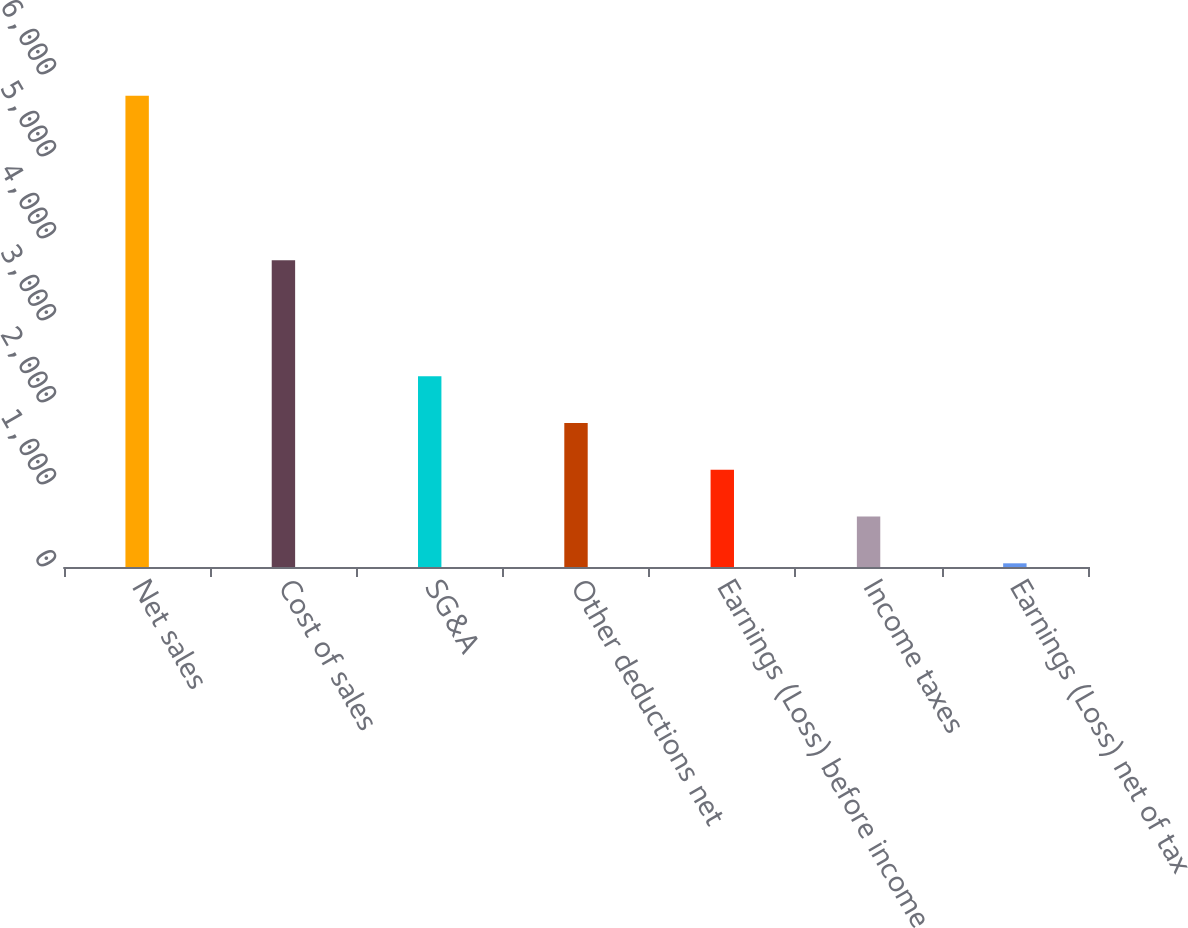Convert chart. <chart><loc_0><loc_0><loc_500><loc_500><bar_chart><fcel>Net sales<fcel>Cost of sales<fcel>SG&A<fcel>Other deductions net<fcel>Earnings (Loss) before income<fcel>Income taxes<fcel>Earnings (Loss) net of tax<nl><fcel>5746<fcel>3741<fcel>2325.4<fcel>1755.3<fcel>1185.2<fcel>615.1<fcel>45<nl></chart> 